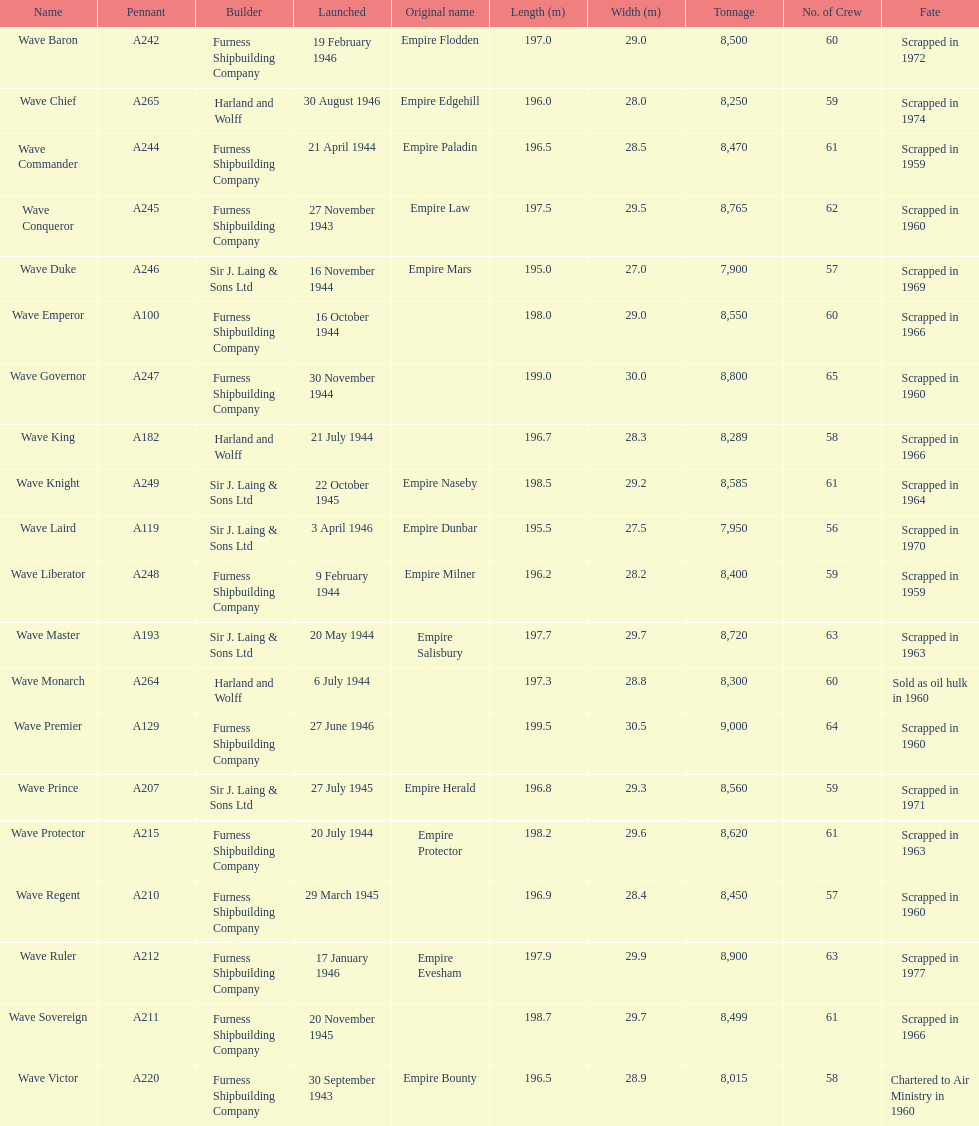What was the next wave class oiler after wave emperor? Wave Duke. 